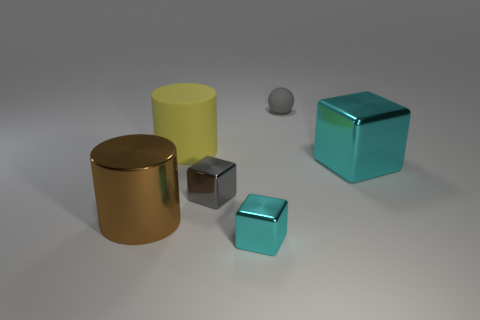What material is the cyan block that is the same size as the brown object?
Provide a short and direct response. Metal. There is a small cube that is to the right of the small gray block; does it have the same color as the thing behind the yellow rubber cylinder?
Provide a succinct answer. No. Is there a yellow object that has the same shape as the large brown object?
Your answer should be very brief. Yes. There is a cyan metal object that is the same size as the gray sphere; what is its shape?
Ensure brevity in your answer.  Cube. What number of big matte things are the same color as the tiny rubber object?
Keep it short and to the point. 0. There is a cylinder on the left side of the large yellow matte object; what size is it?
Your answer should be compact. Large. How many gray shiny things are the same size as the matte cylinder?
Provide a short and direct response. 0. There is a cylinder that is the same material as the tiny gray ball; what is its color?
Offer a terse response. Yellow. Is the number of gray shiny cubes that are behind the large rubber thing less than the number of big things?
Offer a very short reply. Yes. What shape is the tiny object that is the same material as the small cyan block?
Give a very brief answer. Cube. 